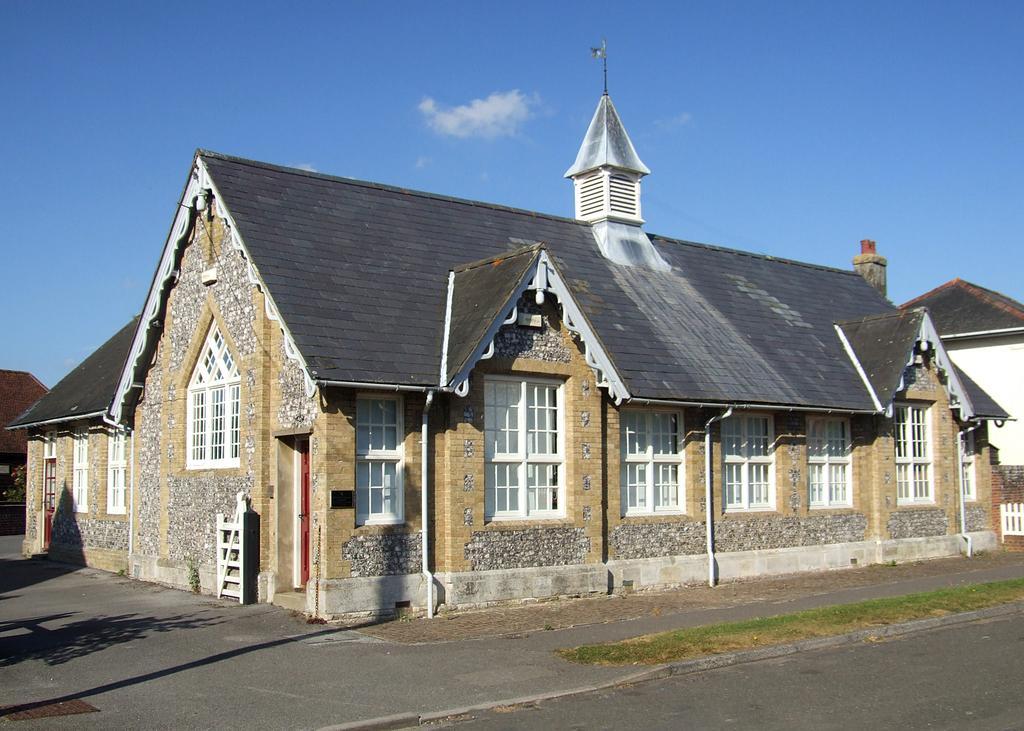In one or two sentences, can you explain what this image depicts? This image is taken outdoors. At the top of the image there is a sky with clouds. At the bottom of the image there is a road and a sidewalk. In the middle of the image there are a few houses with walls, windows, doors and roofs. 